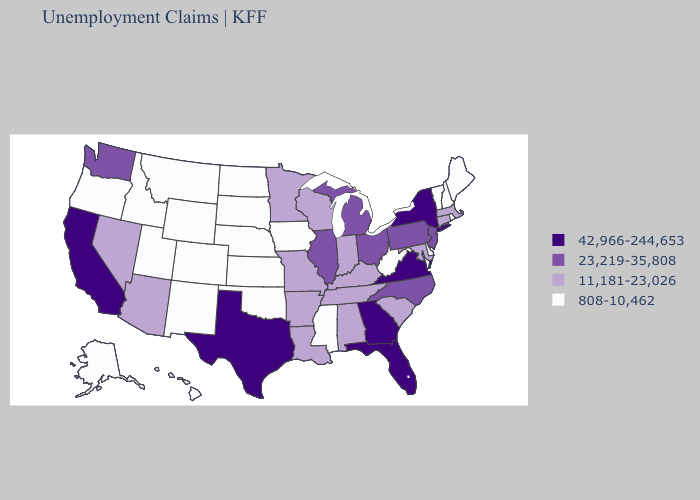Name the states that have a value in the range 42,966-244,653?
Keep it brief. California, Florida, Georgia, New York, Texas, Virginia. Does Missouri have the same value as California?
Be succinct. No. Does Arkansas have the same value as North Carolina?
Short answer required. No. Name the states that have a value in the range 23,219-35,808?
Answer briefly. Illinois, Michigan, New Jersey, North Carolina, Ohio, Pennsylvania, Washington. Does Nebraska have the highest value in the MidWest?
Keep it brief. No. Does Louisiana have the highest value in the USA?
Give a very brief answer. No. Name the states that have a value in the range 42,966-244,653?
Give a very brief answer. California, Florida, Georgia, New York, Texas, Virginia. Name the states that have a value in the range 11,181-23,026?
Keep it brief. Alabama, Arizona, Arkansas, Connecticut, Indiana, Kentucky, Louisiana, Maryland, Massachusetts, Minnesota, Missouri, Nevada, South Carolina, Tennessee, Wisconsin. Does the first symbol in the legend represent the smallest category?
Concise answer only. No. What is the value of Utah?
Quick response, please. 808-10,462. Which states have the highest value in the USA?
Give a very brief answer. California, Florida, Georgia, New York, Texas, Virginia. Does Iowa have the highest value in the USA?
Short answer required. No. What is the value of Pennsylvania?
Short answer required. 23,219-35,808. What is the value of New Mexico?
Answer briefly. 808-10,462. What is the value of Maine?
Short answer required. 808-10,462. 